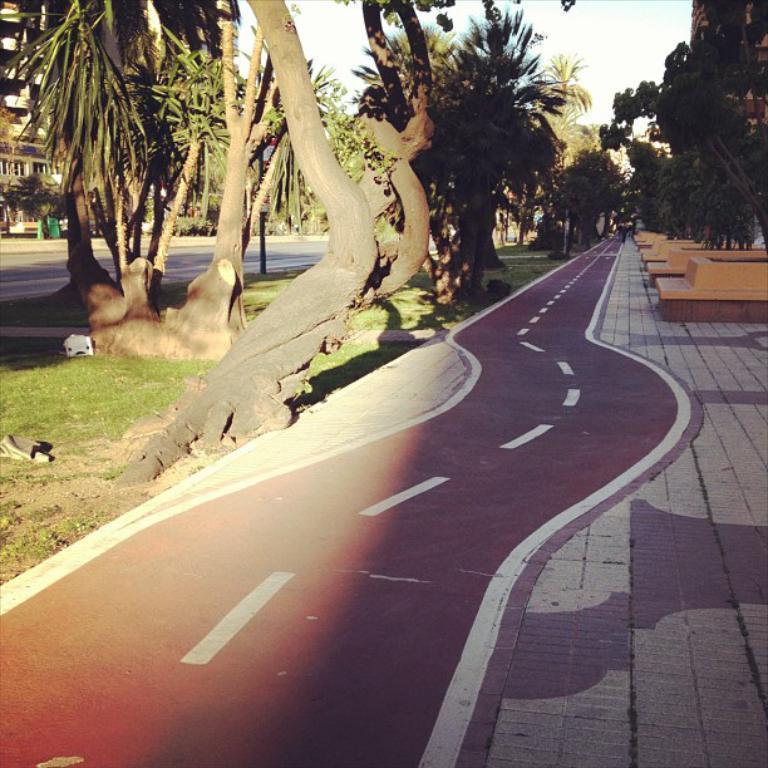In one or two sentences, can you explain what this image depicts? This is a road. Here we can see trees, grass, and buildings. In the background there is sky. 